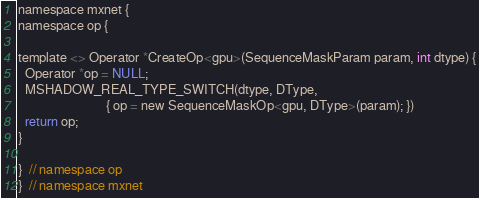Convert code to text. <code><loc_0><loc_0><loc_500><loc_500><_Cuda_>
namespace mxnet {
namespace op {

template <> Operator *CreateOp<gpu>(SequenceMaskParam param, int dtype) {
  Operator *op = NULL;
  MSHADOW_REAL_TYPE_SWITCH(dtype, DType,
                           { op = new SequenceMaskOp<gpu, DType>(param); })
  return op;
}

}  // namespace op
}  // namespace mxnet
</code> 